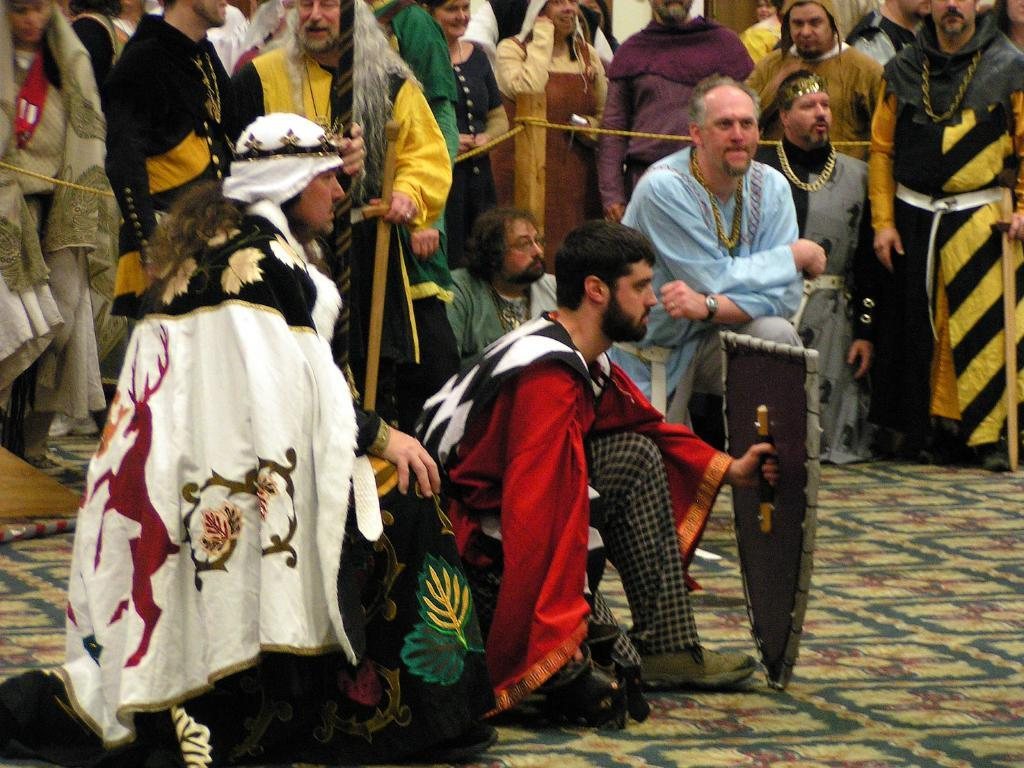What are the people in the image doing? The people in the image are sitting on a mat. Are there any other people visible in the image? Yes, there are other people behind them. What can be seen in the center of the image? There is a fence in the center of the image. What type of food is being served on the mat in the image? There is no food visible on the mat in the image. What type of trousers are the people wearing in the image? The provided facts do not mention the type of trousers the people are wearing in the image. 